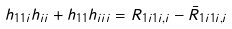Convert formula to latex. <formula><loc_0><loc_0><loc_500><loc_500>h _ { 1 1 i } h _ { i i } + h _ { 1 1 } h _ { i i i } = R _ { 1 i 1 i , i } - \bar { R } _ { 1 i 1 i , i }</formula> 